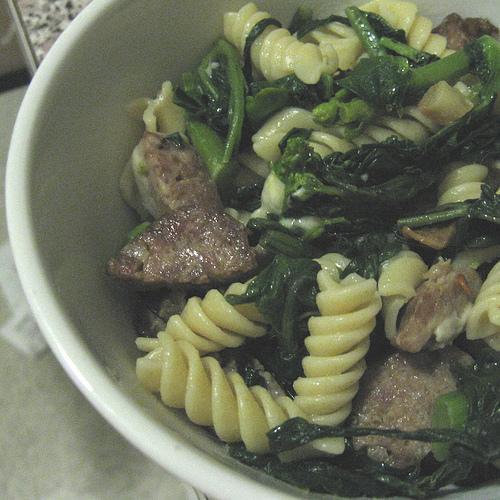How many broccolis can you see?
Give a very brief answer. 2. 